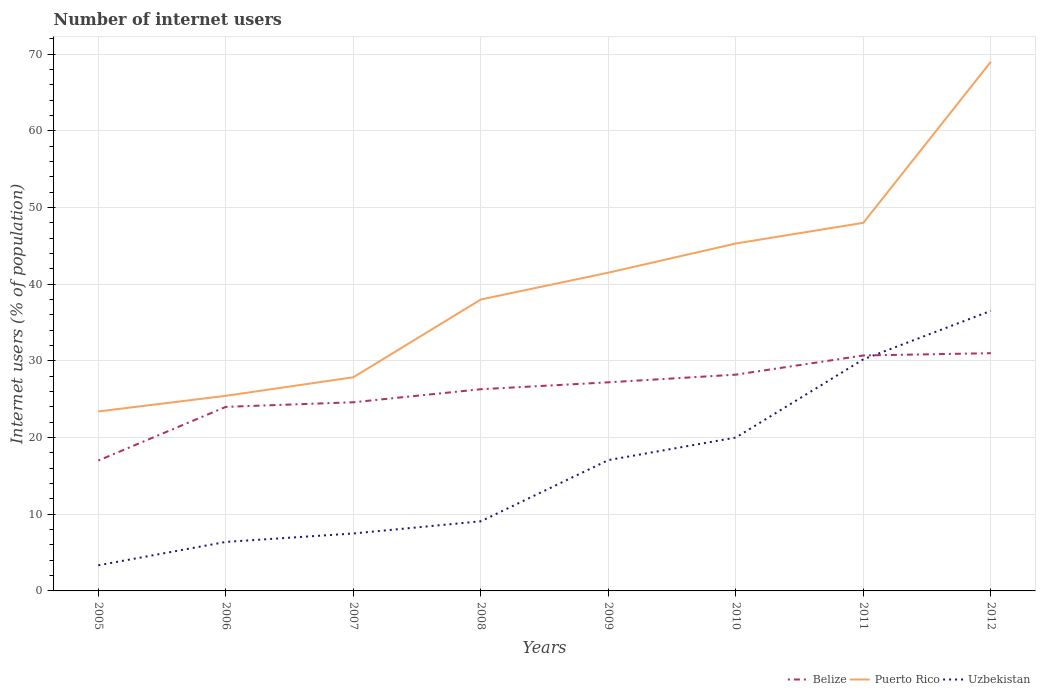Across all years, what is the maximum number of internet users in Belize?
Offer a very short reply. 17. What is the total number of internet users in Uzbekistan in the graph?
Ensure brevity in your answer.  -2.94. What is the difference between the highest and the second highest number of internet users in Uzbekistan?
Provide a short and direct response. 33.18. Is the number of internet users in Uzbekistan strictly greater than the number of internet users in Puerto Rico over the years?
Keep it short and to the point. Yes. How many years are there in the graph?
Make the answer very short. 8. What is the difference between two consecutive major ticks on the Y-axis?
Provide a short and direct response. 10. Are the values on the major ticks of Y-axis written in scientific E-notation?
Your response must be concise. No. Does the graph contain any zero values?
Keep it short and to the point. No. How are the legend labels stacked?
Make the answer very short. Horizontal. What is the title of the graph?
Ensure brevity in your answer.  Number of internet users. Does "Palau" appear as one of the legend labels in the graph?
Provide a short and direct response. No. What is the label or title of the X-axis?
Keep it short and to the point. Years. What is the label or title of the Y-axis?
Your answer should be very brief. Internet users (% of population). What is the Internet users (% of population) in Belize in 2005?
Keep it short and to the point. 17. What is the Internet users (% of population) of Puerto Rico in 2005?
Give a very brief answer. 23.4. What is the Internet users (% of population) of Uzbekistan in 2005?
Keep it short and to the point. 3.34. What is the Internet users (% of population) in Belize in 2006?
Your answer should be compact. 24. What is the Internet users (% of population) of Puerto Rico in 2006?
Make the answer very short. 25.44. What is the Internet users (% of population) in Uzbekistan in 2006?
Keep it short and to the point. 6.39. What is the Internet users (% of population) in Belize in 2007?
Give a very brief answer. 24.6. What is the Internet users (% of population) of Puerto Rico in 2007?
Keep it short and to the point. 27.86. What is the Internet users (% of population) of Uzbekistan in 2007?
Ensure brevity in your answer.  7.49. What is the Internet users (% of population) of Belize in 2008?
Make the answer very short. 26.3. What is the Internet users (% of population) of Puerto Rico in 2008?
Ensure brevity in your answer.  38. What is the Internet users (% of population) in Uzbekistan in 2008?
Give a very brief answer. 9.08. What is the Internet users (% of population) in Belize in 2009?
Provide a short and direct response. 27.2. What is the Internet users (% of population) of Puerto Rico in 2009?
Provide a succinct answer. 41.5. What is the Internet users (% of population) of Uzbekistan in 2009?
Provide a succinct answer. 17.06. What is the Internet users (% of population) of Belize in 2010?
Offer a very short reply. 28.2. What is the Internet users (% of population) of Puerto Rico in 2010?
Make the answer very short. 45.3. What is the Internet users (% of population) in Uzbekistan in 2010?
Provide a short and direct response. 20. What is the Internet users (% of population) of Belize in 2011?
Make the answer very short. 30.7. What is the Internet users (% of population) of Uzbekistan in 2011?
Provide a succinct answer. 30.2. What is the Internet users (% of population) of Puerto Rico in 2012?
Make the answer very short. 69. What is the Internet users (% of population) in Uzbekistan in 2012?
Offer a terse response. 36.52. Across all years, what is the maximum Internet users (% of population) in Belize?
Keep it short and to the point. 31. Across all years, what is the maximum Internet users (% of population) in Puerto Rico?
Provide a short and direct response. 69. Across all years, what is the maximum Internet users (% of population) of Uzbekistan?
Your answer should be very brief. 36.52. Across all years, what is the minimum Internet users (% of population) in Belize?
Ensure brevity in your answer.  17. Across all years, what is the minimum Internet users (% of population) in Puerto Rico?
Your answer should be very brief. 23.4. Across all years, what is the minimum Internet users (% of population) of Uzbekistan?
Your answer should be compact. 3.34. What is the total Internet users (% of population) of Belize in the graph?
Provide a succinct answer. 209. What is the total Internet users (% of population) in Puerto Rico in the graph?
Your answer should be very brief. 318.5. What is the total Internet users (% of population) in Uzbekistan in the graph?
Ensure brevity in your answer.  130.08. What is the difference between the Internet users (% of population) of Belize in 2005 and that in 2006?
Your answer should be very brief. -7. What is the difference between the Internet users (% of population) of Puerto Rico in 2005 and that in 2006?
Offer a terse response. -2.04. What is the difference between the Internet users (% of population) in Uzbekistan in 2005 and that in 2006?
Keep it short and to the point. -3.04. What is the difference between the Internet users (% of population) of Puerto Rico in 2005 and that in 2007?
Your answer should be very brief. -4.46. What is the difference between the Internet users (% of population) in Uzbekistan in 2005 and that in 2007?
Make the answer very short. -4.15. What is the difference between the Internet users (% of population) of Puerto Rico in 2005 and that in 2008?
Provide a succinct answer. -14.6. What is the difference between the Internet users (% of population) in Uzbekistan in 2005 and that in 2008?
Ensure brevity in your answer.  -5.74. What is the difference between the Internet users (% of population) of Puerto Rico in 2005 and that in 2009?
Provide a short and direct response. -18.1. What is the difference between the Internet users (% of population) of Uzbekistan in 2005 and that in 2009?
Offer a very short reply. -13.71. What is the difference between the Internet users (% of population) in Puerto Rico in 2005 and that in 2010?
Keep it short and to the point. -21.9. What is the difference between the Internet users (% of population) of Uzbekistan in 2005 and that in 2010?
Offer a very short reply. -16.66. What is the difference between the Internet users (% of population) of Belize in 2005 and that in 2011?
Keep it short and to the point. -13.7. What is the difference between the Internet users (% of population) of Puerto Rico in 2005 and that in 2011?
Provide a short and direct response. -24.6. What is the difference between the Internet users (% of population) in Uzbekistan in 2005 and that in 2011?
Offer a very short reply. -26.86. What is the difference between the Internet users (% of population) in Puerto Rico in 2005 and that in 2012?
Give a very brief answer. -45.6. What is the difference between the Internet users (% of population) in Uzbekistan in 2005 and that in 2012?
Provide a short and direct response. -33.18. What is the difference between the Internet users (% of population) of Belize in 2006 and that in 2007?
Make the answer very short. -0.6. What is the difference between the Internet users (% of population) of Puerto Rico in 2006 and that in 2007?
Your answer should be compact. -2.42. What is the difference between the Internet users (% of population) of Uzbekistan in 2006 and that in 2007?
Offer a terse response. -1.1. What is the difference between the Internet users (% of population) in Puerto Rico in 2006 and that in 2008?
Your response must be concise. -12.56. What is the difference between the Internet users (% of population) in Uzbekistan in 2006 and that in 2008?
Your response must be concise. -2.69. What is the difference between the Internet users (% of population) of Puerto Rico in 2006 and that in 2009?
Keep it short and to the point. -16.06. What is the difference between the Internet users (% of population) of Uzbekistan in 2006 and that in 2009?
Provide a short and direct response. -10.67. What is the difference between the Internet users (% of population) of Puerto Rico in 2006 and that in 2010?
Offer a very short reply. -19.86. What is the difference between the Internet users (% of population) in Uzbekistan in 2006 and that in 2010?
Your answer should be compact. -13.61. What is the difference between the Internet users (% of population) in Belize in 2006 and that in 2011?
Give a very brief answer. -6.7. What is the difference between the Internet users (% of population) of Puerto Rico in 2006 and that in 2011?
Provide a short and direct response. -22.56. What is the difference between the Internet users (% of population) of Uzbekistan in 2006 and that in 2011?
Offer a very short reply. -23.81. What is the difference between the Internet users (% of population) in Belize in 2006 and that in 2012?
Your answer should be compact. -7. What is the difference between the Internet users (% of population) of Puerto Rico in 2006 and that in 2012?
Your answer should be compact. -43.56. What is the difference between the Internet users (% of population) of Uzbekistan in 2006 and that in 2012?
Your response must be concise. -30.13. What is the difference between the Internet users (% of population) in Belize in 2007 and that in 2008?
Provide a short and direct response. -1.7. What is the difference between the Internet users (% of population) of Puerto Rico in 2007 and that in 2008?
Your answer should be very brief. -10.14. What is the difference between the Internet users (% of population) of Uzbekistan in 2007 and that in 2008?
Your response must be concise. -1.59. What is the difference between the Internet users (% of population) in Puerto Rico in 2007 and that in 2009?
Offer a very short reply. -13.64. What is the difference between the Internet users (% of population) in Uzbekistan in 2007 and that in 2009?
Keep it short and to the point. -9.57. What is the difference between the Internet users (% of population) of Puerto Rico in 2007 and that in 2010?
Offer a very short reply. -17.44. What is the difference between the Internet users (% of population) of Uzbekistan in 2007 and that in 2010?
Keep it short and to the point. -12.51. What is the difference between the Internet users (% of population) of Belize in 2007 and that in 2011?
Offer a very short reply. -6.1. What is the difference between the Internet users (% of population) of Puerto Rico in 2007 and that in 2011?
Provide a succinct answer. -20.14. What is the difference between the Internet users (% of population) in Uzbekistan in 2007 and that in 2011?
Offer a very short reply. -22.71. What is the difference between the Internet users (% of population) in Belize in 2007 and that in 2012?
Keep it short and to the point. -6.4. What is the difference between the Internet users (% of population) of Puerto Rico in 2007 and that in 2012?
Offer a very short reply. -41.14. What is the difference between the Internet users (% of population) of Uzbekistan in 2007 and that in 2012?
Provide a succinct answer. -29.03. What is the difference between the Internet users (% of population) in Uzbekistan in 2008 and that in 2009?
Provide a short and direct response. -7.98. What is the difference between the Internet users (% of population) in Belize in 2008 and that in 2010?
Provide a succinct answer. -1.9. What is the difference between the Internet users (% of population) in Uzbekistan in 2008 and that in 2010?
Provide a succinct answer. -10.92. What is the difference between the Internet users (% of population) of Belize in 2008 and that in 2011?
Keep it short and to the point. -4.4. What is the difference between the Internet users (% of population) in Uzbekistan in 2008 and that in 2011?
Keep it short and to the point. -21.12. What is the difference between the Internet users (% of population) of Puerto Rico in 2008 and that in 2012?
Make the answer very short. -31. What is the difference between the Internet users (% of population) in Uzbekistan in 2008 and that in 2012?
Make the answer very short. -27.44. What is the difference between the Internet users (% of population) in Puerto Rico in 2009 and that in 2010?
Offer a terse response. -3.8. What is the difference between the Internet users (% of population) of Uzbekistan in 2009 and that in 2010?
Offer a terse response. -2.94. What is the difference between the Internet users (% of population) of Uzbekistan in 2009 and that in 2011?
Provide a succinct answer. -13.14. What is the difference between the Internet users (% of population) in Belize in 2009 and that in 2012?
Offer a very short reply. -3.8. What is the difference between the Internet users (% of population) in Puerto Rico in 2009 and that in 2012?
Ensure brevity in your answer.  -27.5. What is the difference between the Internet users (% of population) in Uzbekistan in 2009 and that in 2012?
Your response must be concise. -19.46. What is the difference between the Internet users (% of population) of Belize in 2010 and that in 2011?
Your answer should be compact. -2.5. What is the difference between the Internet users (% of population) of Puerto Rico in 2010 and that in 2011?
Your response must be concise. -2.7. What is the difference between the Internet users (% of population) of Uzbekistan in 2010 and that in 2011?
Offer a terse response. -10.2. What is the difference between the Internet users (% of population) of Puerto Rico in 2010 and that in 2012?
Keep it short and to the point. -23.7. What is the difference between the Internet users (% of population) of Uzbekistan in 2010 and that in 2012?
Your answer should be compact. -16.52. What is the difference between the Internet users (% of population) in Belize in 2011 and that in 2012?
Your response must be concise. -0.3. What is the difference between the Internet users (% of population) in Uzbekistan in 2011 and that in 2012?
Make the answer very short. -6.32. What is the difference between the Internet users (% of population) in Belize in 2005 and the Internet users (% of population) in Puerto Rico in 2006?
Offer a terse response. -8.44. What is the difference between the Internet users (% of population) of Belize in 2005 and the Internet users (% of population) of Uzbekistan in 2006?
Offer a very short reply. 10.61. What is the difference between the Internet users (% of population) in Puerto Rico in 2005 and the Internet users (% of population) in Uzbekistan in 2006?
Offer a terse response. 17.01. What is the difference between the Internet users (% of population) in Belize in 2005 and the Internet users (% of population) in Puerto Rico in 2007?
Give a very brief answer. -10.86. What is the difference between the Internet users (% of population) in Belize in 2005 and the Internet users (% of population) in Uzbekistan in 2007?
Offer a terse response. 9.51. What is the difference between the Internet users (% of population) of Puerto Rico in 2005 and the Internet users (% of population) of Uzbekistan in 2007?
Give a very brief answer. 15.91. What is the difference between the Internet users (% of population) in Belize in 2005 and the Internet users (% of population) in Puerto Rico in 2008?
Provide a short and direct response. -21. What is the difference between the Internet users (% of population) of Belize in 2005 and the Internet users (% of population) of Uzbekistan in 2008?
Offer a terse response. 7.92. What is the difference between the Internet users (% of population) of Puerto Rico in 2005 and the Internet users (% of population) of Uzbekistan in 2008?
Give a very brief answer. 14.32. What is the difference between the Internet users (% of population) in Belize in 2005 and the Internet users (% of population) in Puerto Rico in 2009?
Ensure brevity in your answer.  -24.5. What is the difference between the Internet users (% of population) of Belize in 2005 and the Internet users (% of population) of Uzbekistan in 2009?
Keep it short and to the point. -0.06. What is the difference between the Internet users (% of population) of Puerto Rico in 2005 and the Internet users (% of population) of Uzbekistan in 2009?
Provide a succinct answer. 6.34. What is the difference between the Internet users (% of population) in Belize in 2005 and the Internet users (% of population) in Puerto Rico in 2010?
Keep it short and to the point. -28.3. What is the difference between the Internet users (% of population) of Puerto Rico in 2005 and the Internet users (% of population) of Uzbekistan in 2010?
Your answer should be very brief. 3.4. What is the difference between the Internet users (% of population) in Belize in 2005 and the Internet users (% of population) in Puerto Rico in 2011?
Your response must be concise. -31. What is the difference between the Internet users (% of population) in Puerto Rico in 2005 and the Internet users (% of population) in Uzbekistan in 2011?
Provide a succinct answer. -6.8. What is the difference between the Internet users (% of population) of Belize in 2005 and the Internet users (% of population) of Puerto Rico in 2012?
Your response must be concise. -52. What is the difference between the Internet users (% of population) of Belize in 2005 and the Internet users (% of population) of Uzbekistan in 2012?
Provide a short and direct response. -19.52. What is the difference between the Internet users (% of population) of Puerto Rico in 2005 and the Internet users (% of population) of Uzbekistan in 2012?
Keep it short and to the point. -13.12. What is the difference between the Internet users (% of population) of Belize in 2006 and the Internet users (% of population) of Puerto Rico in 2007?
Give a very brief answer. -3.86. What is the difference between the Internet users (% of population) in Belize in 2006 and the Internet users (% of population) in Uzbekistan in 2007?
Make the answer very short. 16.51. What is the difference between the Internet users (% of population) in Puerto Rico in 2006 and the Internet users (% of population) in Uzbekistan in 2007?
Offer a terse response. 17.95. What is the difference between the Internet users (% of population) in Belize in 2006 and the Internet users (% of population) in Uzbekistan in 2008?
Offer a terse response. 14.92. What is the difference between the Internet users (% of population) of Puerto Rico in 2006 and the Internet users (% of population) of Uzbekistan in 2008?
Your response must be concise. 16.36. What is the difference between the Internet users (% of population) in Belize in 2006 and the Internet users (% of population) in Puerto Rico in 2009?
Your response must be concise. -17.5. What is the difference between the Internet users (% of population) of Belize in 2006 and the Internet users (% of population) of Uzbekistan in 2009?
Make the answer very short. 6.94. What is the difference between the Internet users (% of population) of Puerto Rico in 2006 and the Internet users (% of population) of Uzbekistan in 2009?
Make the answer very short. 8.38. What is the difference between the Internet users (% of population) of Belize in 2006 and the Internet users (% of population) of Puerto Rico in 2010?
Ensure brevity in your answer.  -21.3. What is the difference between the Internet users (% of population) in Puerto Rico in 2006 and the Internet users (% of population) in Uzbekistan in 2010?
Your response must be concise. 5.44. What is the difference between the Internet users (% of population) of Puerto Rico in 2006 and the Internet users (% of population) of Uzbekistan in 2011?
Your answer should be compact. -4.76. What is the difference between the Internet users (% of population) in Belize in 2006 and the Internet users (% of population) in Puerto Rico in 2012?
Provide a short and direct response. -45. What is the difference between the Internet users (% of population) in Belize in 2006 and the Internet users (% of population) in Uzbekistan in 2012?
Your answer should be very brief. -12.52. What is the difference between the Internet users (% of population) in Puerto Rico in 2006 and the Internet users (% of population) in Uzbekistan in 2012?
Provide a succinct answer. -11.08. What is the difference between the Internet users (% of population) in Belize in 2007 and the Internet users (% of population) in Uzbekistan in 2008?
Give a very brief answer. 15.52. What is the difference between the Internet users (% of population) of Puerto Rico in 2007 and the Internet users (% of population) of Uzbekistan in 2008?
Ensure brevity in your answer.  18.78. What is the difference between the Internet users (% of population) of Belize in 2007 and the Internet users (% of population) of Puerto Rico in 2009?
Your answer should be compact. -16.9. What is the difference between the Internet users (% of population) of Belize in 2007 and the Internet users (% of population) of Uzbekistan in 2009?
Your response must be concise. 7.54. What is the difference between the Internet users (% of population) of Puerto Rico in 2007 and the Internet users (% of population) of Uzbekistan in 2009?
Your answer should be very brief. 10.8. What is the difference between the Internet users (% of population) of Belize in 2007 and the Internet users (% of population) of Puerto Rico in 2010?
Offer a terse response. -20.7. What is the difference between the Internet users (% of population) of Belize in 2007 and the Internet users (% of population) of Uzbekistan in 2010?
Offer a terse response. 4.6. What is the difference between the Internet users (% of population) in Puerto Rico in 2007 and the Internet users (% of population) in Uzbekistan in 2010?
Offer a terse response. 7.86. What is the difference between the Internet users (% of population) of Belize in 2007 and the Internet users (% of population) of Puerto Rico in 2011?
Keep it short and to the point. -23.4. What is the difference between the Internet users (% of population) of Belize in 2007 and the Internet users (% of population) of Uzbekistan in 2011?
Offer a terse response. -5.6. What is the difference between the Internet users (% of population) of Puerto Rico in 2007 and the Internet users (% of population) of Uzbekistan in 2011?
Offer a terse response. -2.34. What is the difference between the Internet users (% of population) in Belize in 2007 and the Internet users (% of population) in Puerto Rico in 2012?
Offer a terse response. -44.4. What is the difference between the Internet users (% of population) of Belize in 2007 and the Internet users (% of population) of Uzbekistan in 2012?
Offer a very short reply. -11.92. What is the difference between the Internet users (% of population) in Puerto Rico in 2007 and the Internet users (% of population) in Uzbekistan in 2012?
Make the answer very short. -8.66. What is the difference between the Internet users (% of population) in Belize in 2008 and the Internet users (% of population) in Puerto Rico in 2009?
Ensure brevity in your answer.  -15.2. What is the difference between the Internet users (% of population) of Belize in 2008 and the Internet users (% of population) of Uzbekistan in 2009?
Give a very brief answer. 9.24. What is the difference between the Internet users (% of population) in Puerto Rico in 2008 and the Internet users (% of population) in Uzbekistan in 2009?
Provide a short and direct response. 20.94. What is the difference between the Internet users (% of population) of Belize in 2008 and the Internet users (% of population) of Puerto Rico in 2010?
Your answer should be compact. -19. What is the difference between the Internet users (% of population) of Puerto Rico in 2008 and the Internet users (% of population) of Uzbekistan in 2010?
Give a very brief answer. 18. What is the difference between the Internet users (% of population) of Belize in 2008 and the Internet users (% of population) of Puerto Rico in 2011?
Provide a succinct answer. -21.7. What is the difference between the Internet users (% of population) in Puerto Rico in 2008 and the Internet users (% of population) in Uzbekistan in 2011?
Your response must be concise. 7.8. What is the difference between the Internet users (% of population) in Belize in 2008 and the Internet users (% of population) in Puerto Rico in 2012?
Make the answer very short. -42.7. What is the difference between the Internet users (% of population) in Belize in 2008 and the Internet users (% of population) in Uzbekistan in 2012?
Offer a very short reply. -10.22. What is the difference between the Internet users (% of population) of Puerto Rico in 2008 and the Internet users (% of population) of Uzbekistan in 2012?
Offer a very short reply. 1.48. What is the difference between the Internet users (% of population) of Belize in 2009 and the Internet users (% of population) of Puerto Rico in 2010?
Give a very brief answer. -18.1. What is the difference between the Internet users (% of population) of Belize in 2009 and the Internet users (% of population) of Puerto Rico in 2011?
Give a very brief answer. -20.8. What is the difference between the Internet users (% of population) in Belize in 2009 and the Internet users (% of population) in Puerto Rico in 2012?
Offer a terse response. -41.8. What is the difference between the Internet users (% of population) in Belize in 2009 and the Internet users (% of population) in Uzbekistan in 2012?
Your answer should be very brief. -9.32. What is the difference between the Internet users (% of population) of Puerto Rico in 2009 and the Internet users (% of population) of Uzbekistan in 2012?
Provide a succinct answer. 4.98. What is the difference between the Internet users (% of population) of Belize in 2010 and the Internet users (% of population) of Puerto Rico in 2011?
Offer a very short reply. -19.8. What is the difference between the Internet users (% of population) in Puerto Rico in 2010 and the Internet users (% of population) in Uzbekistan in 2011?
Ensure brevity in your answer.  15.1. What is the difference between the Internet users (% of population) of Belize in 2010 and the Internet users (% of population) of Puerto Rico in 2012?
Ensure brevity in your answer.  -40.8. What is the difference between the Internet users (% of population) of Belize in 2010 and the Internet users (% of population) of Uzbekistan in 2012?
Give a very brief answer. -8.32. What is the difference between the Internet users (% of population) in Puerto Rico in 2010 and the Internet users (% of population) in Uzbekistan in 2012?
Keep it short and to the point. 8.78. What is the difference between the Internet users (% of population) in Belize in 2011 and the Internet users (% of population) in Puerto Rico in 2012?
Your answer should be compact. -38.3. What is the difference between the Internet users (% of population) in Belize in 2011 and the Internet users (% of population) in Uzbekistan in 2012?
Provide a short and direct response. -5.82. What is the difference between the Internet users (% of population) in Puerto Rico in 2011 and the Internet users (% of population) in Uzbekistan in 2012?
Offer a terse response. 11.48. What is the average Internet users (% of population) of Belize per year?
Offer a very short reply. 26.12. What is the average Internet users (% of population) in Puerto Rico per year?
Make the answer very short. 39.81. What is the average Internet users (% of population) of Uzbekistan per year?
Your response must be concise. 16.26. In the year 2005, what is the difference between the Internet users (% of population) in Belize and Internet users (% of population) in Puerto Rico?
Your response must be concise. -6.4. In the year 2005, what is the difference between the Internet users (% of population) of Belize and Internet users (% of population) of Uzbekistan?
Give a very brief answer. 13.66. In the year 2005, what is the difference between the Internet users (% of population) of Puerto Rico and Internet users (% of population) of Uzbekistan?
Your answer should be very brief. 20.06. In the year 2006, what is the difference between the Internet users (% of population) in Belize and Internet users (% of population) in Puerto Rico?
Give a very brief answer. -1.44. In the year 2006, what is the difference between the Internet users (% of population) in Belize and Internet users (% of population) in Uzbekistan?
Offer a very short reply. 17.61. In the year 2006, what is the difference between the Internet users (% of population) of Puerto Rico and Internet users (% of population) of Uzbekistan?
Your answer should be very brief. 19.05. In the year 2007, what is the difference between the Internet users (% of population) in Belize and Internet users (% of population) in Puerto Rico?
Your answer should be very brief. -3.26. In the year 2007, what is the difference between the Internet users (% of population) of Belize and Internet users (% of population) of Uzbekistan?
Make the answer very short. 17.11. In the year 2007, what is the difference between the Internet users (% of population) in Puerto Rico and Internet users (% of population) in Uzbekistan?
Make the answer very short. 20.37. In the year 2008, what is the difference between the Internet users (% of population) of Belize and Internet users (% of population) of Uzbekistan?
Your answer should be very brief. 17.22. In the year 2008, what is the difference between the Internet users (% of population) in Puerto Rico and Internet users (% of population) in Uzbekistan?
Offer a terse response. 28.92. In the year 2009, what is the difference between the Internet users (% of population) of Belize and Internet users (% of population) of Puerto Rico?
Provide a short and direct response. -14.3. In the year 2009, what is the difference between the Internet users (% of population) in Belize and Internet users (% of population) in Uzbekistan?
Your answer should be very brief. 10.14. In the year 2009, what is the difference between the Internet users (% of population) of Puerto Rico and Internet users (% of population) of Uzbekistan?
Provide a succinct answer. 24.44. In the year 2010, what is the difference between the Internet users (% of population) of Belize and Internet users (% of population) of Puerto Rico?
Your response must be concise. -17.1. In the year 2010, what is the difference between the Internet users (% of population) in Belize and Internet users (% of population) in Uzbekistan?
Your answer should be very brief. 8.2. In the year 2010, what is the difference between the Internet users (% of population) in Puerto Rico and Internet users (% of population) in Uzbekistan?
Your answer should be compact. 25.3. In the year 2011, what is the difference between the Internet users (% of population) of Belize and Internet users (% of population) of Puerto Rico?
Provide a short and direct response. -17.3. In the year 2011, what is the difference between the Internet users (% of population) in Puerto Rico and Internet users (% of population) in Uzbekistan?
Your answer should be compact. 17.8. In the year 2012, what is the difference between the Internet users (% of population) in Belize and Internet users (% of population) in Puerto Rico?
Provide a succinct answer. -38. In the year 2012, what is the difference between the Internet users (% of population) of Belize and Internet users (% of population) of Uzbekistan?
Provide a short and direct response. -5.52. In the year 2012, what is the difference between the Internet users (% of population) of Puerto Rico and Internet users (% of population) of Uzbekistan?
Provide a succinct answer. 32.48. What is the ratio of the Internet users (% of population) in Belize in 2005 to that in 2006?
Your answer should be compact. 0.71. What is the ratio of the Internet users (% of population) in Puerto Rico in 2005 to that in 2006?
Offer a very short reply. 0.92. What is the ratio of the Internet users (% of population) of Uzbekistan in 2005 to that in 2006?
Your response must be concise. 0.52. What is the ratio of the Internet users (% of population) in Belize in 2005 to that in 2007?
Ensure brevity in your answer.  0.69. What is the ratio of the Internet users (% of population) in Puerto Rico in 2005 to that in 2007?
Ensure brevity in your answer.  0.84. What is the ratio of the Internet users (% of population) of Uzbekistan in 2005 to that in 2007?
Your response must be concise. 0.45. What is the ratio of the Internet users (% of population) in Belize in 2005 to that in 2008?
Provide a short and direct response. 0.65. What is the ratio of the Internet users (% of population) in Puerto Rico in 2005 to that in 2008?
Provide a short and direct response. 0.62. What is the ratio of the Internet users (% of population) of Uzbekistan in 2005 to that in 2008?
Offer a terse response. 0.37. What is the ratio of the Internet users (% of population) in Puerto Rico in 2005 to that in 2009?
Your answer should be very brief. 0.56. What is the ratio of the Internet users (% of population) in Uzbekistan in 2005 to that in 2009?
Make the answer very short. 0.2. What is the ratio of the Internet users (% of population) in Belize in 2005 to that in 2010?
Your answer should be compact. 0.6. What is the ratio of the Internet users (% of population) in Puerto Rico in 2005 to that in 2010?
Ensure brevity in your answer.  0.52. What is the ratio of the Internet users (% of population) of Uzbekistan in 2005 to that in 2010?
Your answer should be very brief. 0.17. What is the ratio of the Internet users (% of population) in Belize in 2005 to that in 2011?
Your response must be concise. 0.55. What is the ratio of the Internet users (% of population) in Puerto Rico in 2005 to that in 2011?
Make the answer very short. 0.49. What is the ratio of the Internet users (% of population) of Uzbekistan in 2005 to that in 2011?
Provide a short and direct response. 0.11. What is the ratio of the Internet users (% of population) of Belize in 2005 to that in 2012?
Your answer should be very brief. 0.55. What is the ratio of the Internet users (% of population) in Puerto Rico in 2005 to that in 2012?
Your answer should be very brief. 0.34. What is the ratio of the Internet users (% of population) of Uzbekistan in 2005 to that in 2012?
Offer a very short reply. 0.09. What is the ratio of the Internet users (% of population) in Belize in 2006 to that in 2007?
Offer a very short reply. 0.98. What is the ratio of the Internet users (% of population) in Puerto Rico in 2006 to that in 2007?
Make the answer very short. 0.91. What is the ratio of the Internet users (% of population) of Uzbekistan in 2006 to that in 2007?
Offer a terse response. 0.85. What is the ratio of the Internet users (% of population) of Belize in 2006 to that in 2008?
Your answer should be very brief. 0.91. What is the ratio of the Internet users (% of population) of Puerto Rico in 2006 to that in 2008?
Offer a terse response. 0.67. What is the ratio of the Internet users (% of population) in Uzbekistan in 2006 to that in 2008?
Ensure brevity in your answer.  0.7. What is the ratio of the Internet users (% of population) in Belize in 2006 to that in 2009?
Your answer should be very brief. 0.88. What is the ratio of the Internet users (% of population) of Puerto Rico in 2006 to that in 2009?
Make the answer very short. 0.61. What is the ratio of the Internet users (% of population) of Uzbekistan in 2006 to that in 2009?
Offer a terse response. 0.37. What is the ratio of the Internet users (% of population) of Belize in 2006 to that in 2010?
Give a very brief answer. 0.85. What is the ratio of the Internet users (% of population) in Puerto Rico in 2006 to that in 2010?
Offer a terse response. 0.56. What is the ratio of the Internet users (% of population) in Uzbekistan in 2006 to that in 2010?
Offer a terse response. 0.32. What is the ratio of the Internet users (% of population) in Belize in 2006 to that in 2011?
Your answer should be very brief. 0.78. What is the ratio of the Internet users (% of population) of Puerto Rico in 2006 to that in 2011?
Offer a very short reply. 0.53. What is the ratio of the Internet users (% of population) of Uzbekistan in 2006 to that in 2011?
Ensure brevity in your answer.  0.21. What is the ratio of the Internet users (% of population) of Belize in 2006 to that in 2012?
Offer a very short reply. 0.77. What is the ratio of the Internet users (% of population) of Puerto Rico in 2006 to that in 2012?
Your answer should be compact. 0.37. What is the ratio of the Internet users (% of population) of Uzbekistan in 2006 to that in 2012?
Offer a very short reply. 0.17. What is the ratio of the Internet users (% of population) of Belize in 2007 to that in 2008?
Make the answer very short. 0.94. What is the ratio of the Internet users (% of population) of Puerto Rico in 2007 to that in 2008?
Ensure brevity in your answer.  0.73. What is the ratio of the Internet users (% of population) of Uzbekistan in 2007 to that in 2008?
Provide a short and direct response. 0.82. What is the ratio of the Internet users (% of population) of Belize in 2007 to that in 2009?
Your answer should be very brief. 0.9. What is the ratio of the Internet users (% of population) in Puerto Rico in 2007 to that in 2009?
Offer a very short reply. 0.67. What is the ratio of the Internet users (% of population) in Uzbekistan in 2007 to that in 2009?
Your response must be concise. 0.44. What is the ratio of the Internet users (% of population) of Belize in 2007 to that in 2010?
Your answer should be compact. 0.87. What is the ratio of the Internet users (% of population) in Puerto Rico in 2007 to that in 2010?
Provide a short and direct response. 0.61. What is the ratio of the Internet users (% of population) in Uzbekistan in 2007 to that in 2010?
Your answer should be very brief. 0.37. What is the ratio of the Internet users (% of population) of Belize in 2007 to that in 2011?
Your answer should be compact. 0.8. What is the ratio of the Internet users (% of population) in Puerto Rico in 2007 to that in 2011?
Your response must be concise. 0.58. What is the ratio of the Internet users (% of population) of Uzbekistan in 2007 to that in 2011?
Offer a terse response. 0.25. What is the ratio of the Internet users (% of population) in Belize in 2007 to that in 2012?
Keep it short and to the point. 0.79. What is the ratio of the Internet users (% of population) of Puerto Rico in 2007 to that in 2012?
Your response must be concise. 0.4. What is the ratio of the Internet users (% of population) in Uzbekistan in 2007 to that in 2012?
Your answer should be very brief. 0.21. What is the ratio of the Internet users (% of population) of Belize in 2008 to that in 2009?
Offer a terse response. 0.97. What is the ratio of the Internet users (% of population) of Puerto Rico in 2008 to that in 2009?
Keep it short and to the point. 0.92. What is the ratio of the Internet users (% of population) of Uzbekistan in 2008 to that in 2009?
Provide a short and direct response. 0.53. What is the ratio of the Internet users (% of population) in Belize in 2008 to that in 2010?
Keep it short and to the point. 0.93. What is the ratio of the Internet users (% of population) of Puerto Rico in 2008 to that in 2010?
Make the answer very short. 0.84. What is the ratio of the Internet users (% of population) in Uzbekistan in 2008 to that in 2010?
Give a very brief answer. 0.45. What is the ratio of the Internet users (% of population) of Belize in 2008 to that in 2011?
Your response must be concise. 0.86. What is the ratio of the Internet users (% of population) in Puerto Rico in 2008 to that in 2011?
Provide a short and direct response. 0.79. What is the ratio of the Internet users (% of population) in Uzbekistan in 2008 to that in 2011?
Provide a short and direct response. 0.3. What is the ratio of the Internet users (% of population) in Belize in 2008 to that in 2012?
Offer a very short reply. 0.85. What is the ratio of the Internet users (% of population) of Puerto Rico in 2008 to that in 2012?
Make the answer very short. 0.55. What is the ratio of the Internet users (% of population) of Uzbekistan in 2008 to that in 2012?
Give a very brief answer. 0.25. What is the ratio of the Internet users (% of population) in Belize in 2009 to that in 2010?
Offer a terse response. 0.96. What is the ratio of the Internet users (% of population) in Puerto Rico in 2009 to that in 2010?
Ensure brevity in your answer.  0.92. What is the ratio of the Internet users (% of population) in Uzbekistan in 2009 to that in 2010?
Make the answer very short. 0.85. What is the ratio of the Internet users (% of population) of Belize in 2009 to that in 2011?
Offer a terse response. 0.89. What is the ratio of the Internet users (% of population) of Puerto Rico in 2009 to that in 2011?
Provide a short and direct response. 0.86. What is the ratio of the Internet users (% of population) of Uzbekistan in 2009 to that in 2011?
Ensure brevity in your answer.  0.56. What is the ratio of the Internet users (% of population) in Belize in 2009 to that in 2012?
Make the answer very short. 0.88. What is the ratio of the Internet users (% of population) in Puerto Rico in 2009 to that in 2012?
Your answer should be compact. 0.6. What is the ratio of the Internet users (% of population) in Uzbekistan in 2009 to that in 2012?
Offer a very short reply. 0.47. What is the ratio of the Internet users (% of population) in Belize in 2010 to that in 2011?
Offer a terse response. 0.92. What is the ratio of the Internet users (% of population) of Puerto Rico in 2010 to that in 2011?
Your answer should be compact. 0.94. What is the ratio of the Internet users (% of population) of Uzbekistan in 2010 to that in 2011?
Your answer should be very brief. 0.66. What is the ratio of the Internet users (% of population) in Belize in 2010 to that in 2012?
Make the answer very short. 0.91. What is the ratio of the Internet users (% of population) of Puerto Rico in 2010 to that in 2012?
Ensure brevity in your answer.  0.66. What is the ratio of the Internet users (% of population) in Uzbekistan in 2010 to that in 2012?
Your response must be concise. 0.55. What is the ratio of the Internet users (% of population) of Belize in 2011 to that in 2012?
Ensure brevity in your answer.  0.99. What is the ratio of the Internet users (% of population) of Puerto Rico in 2011 to that in 2012?
Provide a succinct answer. 0.7. What is the ratio of the Internet users (% of population) of Uzbekistan in 2011 to that in 2012?
Provide a short and direct response. 0.83. What is the difference between the highest and the second highest Internet users (% of population) of Belize?
Offer a terse response. 0.3. What is the difference between the highest and the second highest Internet users (% of population) in Uzbekistan?
Your answer should be very brief. 6.32. What is the difference between the highest and the lowest Internet users (% of population) in Puerto Rico?
Make the answer very short. 45.6. What is the difference between the highest and the lowest Internet users (% of population) in Uzbekistan?
Provide a succinct answer. 33.18. 